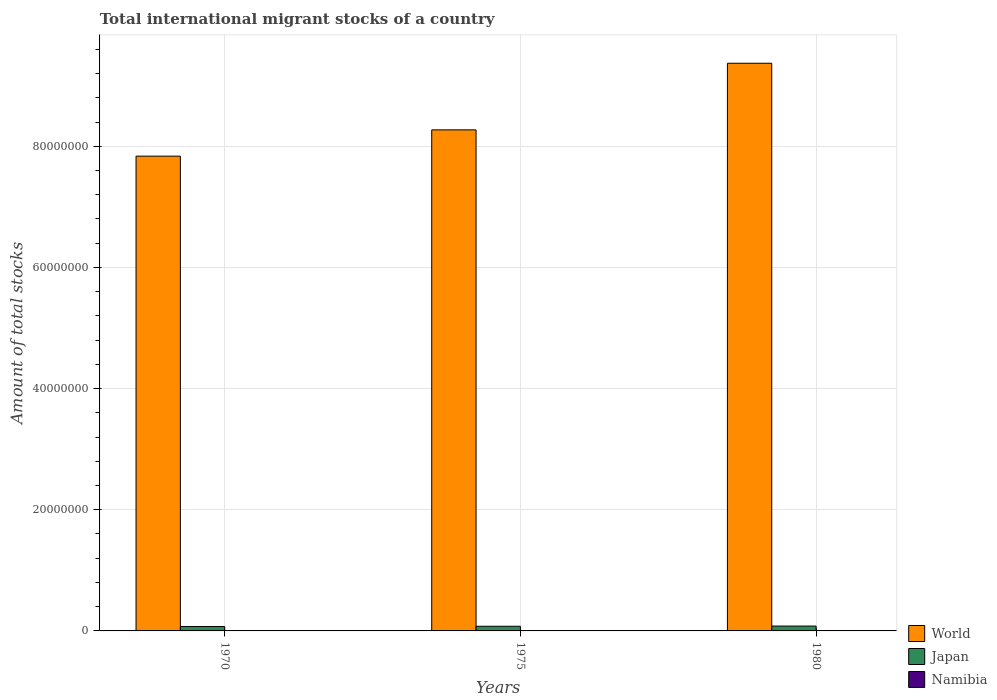Are the number of bars per tick equal to the number of legend labels?
Offer a very short reply. Yes. Are the number of bars on each tick of the X-axis equal?
Ensure brevity in your answer.  Yes. How many bars are there on the 2nd tick from the right?
Ensure brevity in your answer.  3. What is the label of the 2nd group of bars from the left?
Your response must be concise. 1975. In how many cases, is the number of bars for a given year not equal to the number of legend labels?
Keep it short and to the point. 0. What is the amount of total stocks in in World in 1975?
Keep it short and to the point. 8.27e+07. Across all years, what is the maximum amount of total stocks in in Japan?
Offer a terse response. 8.02e+05. Across all years, what is the minimum amount of total stocks in in World?
Your answer should be very brief. 7.84e+07. In which year was the amount of total stocks in in Japan minimum?
Your response must be concise. 1970. What is the total amount of total stocks in in Namibia in the graph?
Ensure brevity in your answer.  1.69e+05. What is the difference between the amount of total stocks in in World in 1975 and that in 1980?
Your response must be concise. -1.10e+07. What is the difference between the amount of total stocks in in Namibia in 1975 and the amount of total stocks in in World in 1980?
Offer a terse response. -9.36e+07. What is the average amount of total stocks in in World per year?
Give a very brief answer. 8.49e+07. In the year 1970, what is the difference between the amount of total stocks in in Namibia and amount of total stocks in in Japan?
Offer a very short reply. -6.82e+05. What is the ratio of the amount of total stocks in in World in 1975 to that in 1980?
Give a very brief answer. 0.88. What is the difference between the highest and the second highest amount of total stocks in in Namibia?
Offer a very short reply. 1.47e+04. What is the difference between the highest and the lowest amount of total stocks in in Japan?
Your answer should be very brief. 7.73e+04. Is the sum of the amount of total stocks in in Namibia in 1970 and 1980 greater than the maximum amount of total stocks in in World across all years?
Provide a succinct answer. No. What does the 3rd bar from the left in 1980 represents?
Make the answer very short. Namibia. Are all the bars in the graph horizontal?
Ensure brevity in your answer.  No. What is the difference between two consecutive major ticks on the Y-axis?
Keep it short and to the point. 2.00e+07. Are the values on the major ticks of Y-axis written in scientific E-notation?
Offer a terse response. No. How many legend labels are there?
Your answer should be compact. 3. How are the legend labels stacked?
Ensure brevity in your answer.  Vertical. What is the title of the graph?
Your answer should be very brief. Total international migrant stocks of a country. What is the label or title of the X-axis?
Your response must be concise. Years. What is the label or title of the Y-axis?
Keep it short and to the point. Amount of total stocks. What is the Amount of total stocks in World in 1970?
Offer a terse response. 7.84e+07. What is the Amount of total stocks of Japan in 1970?
Provide a short and direct response. 7.25e+05. What is the Amount of total stocks in Namibia in 1970?
Provide a succinct answer. 4.36e+04. What is the Amount of total stocks in World in 1975?
Give a very brief answer. 8.27e+07. What is the Amount of total stocks of Japan in 1975?
Provide a short and direct response. 7.70e+05. What is the Amount of total stocks in Namibia in 1975?
Provide a succinct answer. 5.52e+04. What is the Amount of total stocks of World in 1980?
Your answer should be very brief. 9.37e+07. What is the Amount of total stocks in Japan in 1980?
Keep it short and to the point. 8.02e+05. What is the Amount of total stocks in Namibia in 1980?
Keep it short and to the point. 6.99e+04. Across all years, what is the maximum Amount of total stocks in World?
Give a very brief answer. 9.37e+07. Across all years, what is the maximum Amount of total stocks of Japan?
Make the answer very short. 8.02e+05. Across all years, what is the maximum Amount of total stocks of Namibia?
Give a very brief answer. 6.99e+04. Across all years, what is the minimum Amount of total stocks in World?
Offer a very short reply. 7.84e+07. Across all years, what is the minimum Amount of total stocks of Japan?
Your answer should be very brief. 7.25e+05. Across all years, what is the minimum Amount of total stocks in Namibia?
Offer a very short reply. 4.36e+04. What is the total Amount of total stocks in World in the graph?
Ensure brevity in your answer.  2.55e+08. What is the total Amount of total stocks of Japan in the graph?
Your response must be concise. 2.30e+06. What is the total Amount of total stocks in Namibia in the graph?
Your response must be concise. 1.69e+05. What is the difference between the Amount of total stocks in World in 1970 and that in 1975?
Ensure brevity in your answer.  -4.34e+06. What is the difference between the Amount of total stocks of Japan in 1970 and that in 1975?
Offer a very short reply. -4.52e+04. What is the difference between the Amount of total stocks in Namibia in 1970 and that in 1975?
Your answer should be compact. -1.16e+04. What is the difference between the Amount of total stocks of World in 1970 and that in 1980?
Keep it short and to the point. -1.53e+07. What is the difference between the Amount of total stocks of Japan in 1970 and that in 1980?
Offer a terse response. -7.73e+04. What is the difference between the Amount of total stocks of Namibia in 1970 and that in 1980?
Keep it short and to the point. -2.63e+04. What is the difference between the Amount of total stocks of World in 1975 and that in 1980?
Offer a very short reply. -1.10e+07. What is the difference between the Amount of total stocks of Japan in 1975 and that in 1980?
Keep it short and to the point. -3.21e+04. What is the difference between the Amount of total stocks of Namibia in 1975 and that in 1980?
Make the answer very short. -1.47e+04. What is the difference between the Amount of total stocks of World in 1970 and the Amount of total stocks of Japan in 1975?
Your response must be concise. 7.76e+07. What is the difference between the Amount of total stocks in World in 1970 and the Amount of total stocks in Namibia in 1975?
Provide a succinct answer. 7.83e+07. What is the difference between the Amount of total stocks in Japan in 1970 and the Amount of total stocks in Namibia in 1975?
Offer a very short reply. 6.70e+05. What is the difference between the Amount of total stocks in World in 1970 and the Amount of total stocks in Japan in 1980?
Your response must be concise. 7.76e+07. What is the difference between the Amount of total stocks in World in 1970 and the Amount of total stocks in Namibia in 1980?
Your answer should be compact. 7.83e+07. What is the difference between the Amount of total stocks in Japan in 1970 and the Amount of total stocks in Namibia in 1980?
Keep it short and to the point. 6.55e+05. What is the difference between the Amount of total stocks in World in 1975 and the Amount of total stocks in Japan in 1980?
Keep it short and to the point. 8.19e+07. What is the difference between the Amount of total stocks in World in 1975 and the Amount of total stocks in Namibia in 1980?
Your answer should be compact. 8.26e+07. What is the difference between the Amount of total stocks of Japan in 1975 and the Amount of total stocks of Namibia in 1980?
Your answer should be compact. 7.00e+05. What is the average Amount of total stocks in World per year?
Ensure brevity in your answer.  8.49e+07. What is the average Amount of total stocks of Japan per year?
Keep it short and to the point. 7.66e+05. What is the average Amount of total stocks of Namibia per year?
Ensure brevity in your answer.  5.63e+04. In the year 1970, what is the difference between the Amount of total stocks of World and Amount of total stocks of Japan?
Your response must be concise. 7.76e+07. In the year 1970, what is the difference between the Amount of total stocks of World and Amount of total stocks of Namibia?
Your response must be concise. 7.83e+07. In the year 1970, what is the difference between the Amount of total stocks in Japan and Amount of total stocks in Namibia?
Provide a succinct answer. 6.82e+05. In the year 1975, what is the difference between the Amount of total stocks of World and Amount of total stocks of Japan?
Offer a terse response. 8.19e+07. In the year 1975, what is the difference between the Amount of total stocks in World and Amount of total stocks in Namibia?
Offer a terse response. 8.27e+07. In the year 1975, what is the difference between the Amount of total stocks in Japan and Amount of total stocks in Namibia?
Your response must be concise. 7.15e+05. In the year 1980, what is the difference between the Amount of total stocks in World and Amount of total stocks in Japan?
Offer a very short reply. 9.29e+07. In the year 1980, what is the difference between the Amount of total stocks in World and Amount of total stocks in Namibia?
Provide a short and direct response. 9.36e+07. In the year 1980, what is the difference between the Amount of total stocks of Japan and Amount of total stocks of Namibia?
Your response must be concise. 7.32e+05. What is the ratio of the Amount of total stocks in World in 1970 to that in 1975?
Provide a short and direct response. 0.95. What is the ratio of the Amount of total stocks of Japan in 1970 to that in 1975?
Offer a very short reply. 0.94. What is the ratio of the Amount of total stocks in Namibia in 1970 to that in 1975?
Ensure brevity in your answer.  0.79. What is the ratio of the Amount of total stocks of World in 1970 to that in 1980?
Your response must be concise. 0.84. What is the ratio of the Amount of total stocks of Japan in 1970 to that in 1980?
Provide a succinct answer. 0.9. What is the ratio of the Amount of total stocks of Namibia in 1970 to that in 1980?
Your answer should be very brief. 0.62. What is the ratio of the Amount of total stocks in World in 1975 to that in 1980?
Provide a succinct answer. 0.88. What is the ratio of the Amount of total stocks in Namibia in 1975 to that in 1980?
Offer a very short reply. 0.79. What is the difference between the highest and the second highest Amount of total stocks in World?
Ensure brevity in your answer.  1.10e+07. What is the difference between the highest and the second highest Amount of total stocks in Japan?
Provide a succinct answer. 3.21e+04. What is the difference between the highest and the second highest Amount of total stocks in Namibia?
Ensure brevity in your answer.  1.47e+04. What is the difference between the highest and the lowest Amount of total stocks in World?
Offer a very short reply. 1.53e+07. What is the difference between the highest and the lowest Amount of total stocks in Japan?
Your answer should be compact. 7.73e+04. What is the difference between the highest and the lowest Amount of total stocks in Namibia?
Ensure brevity in your answer.  2.63e+04. 